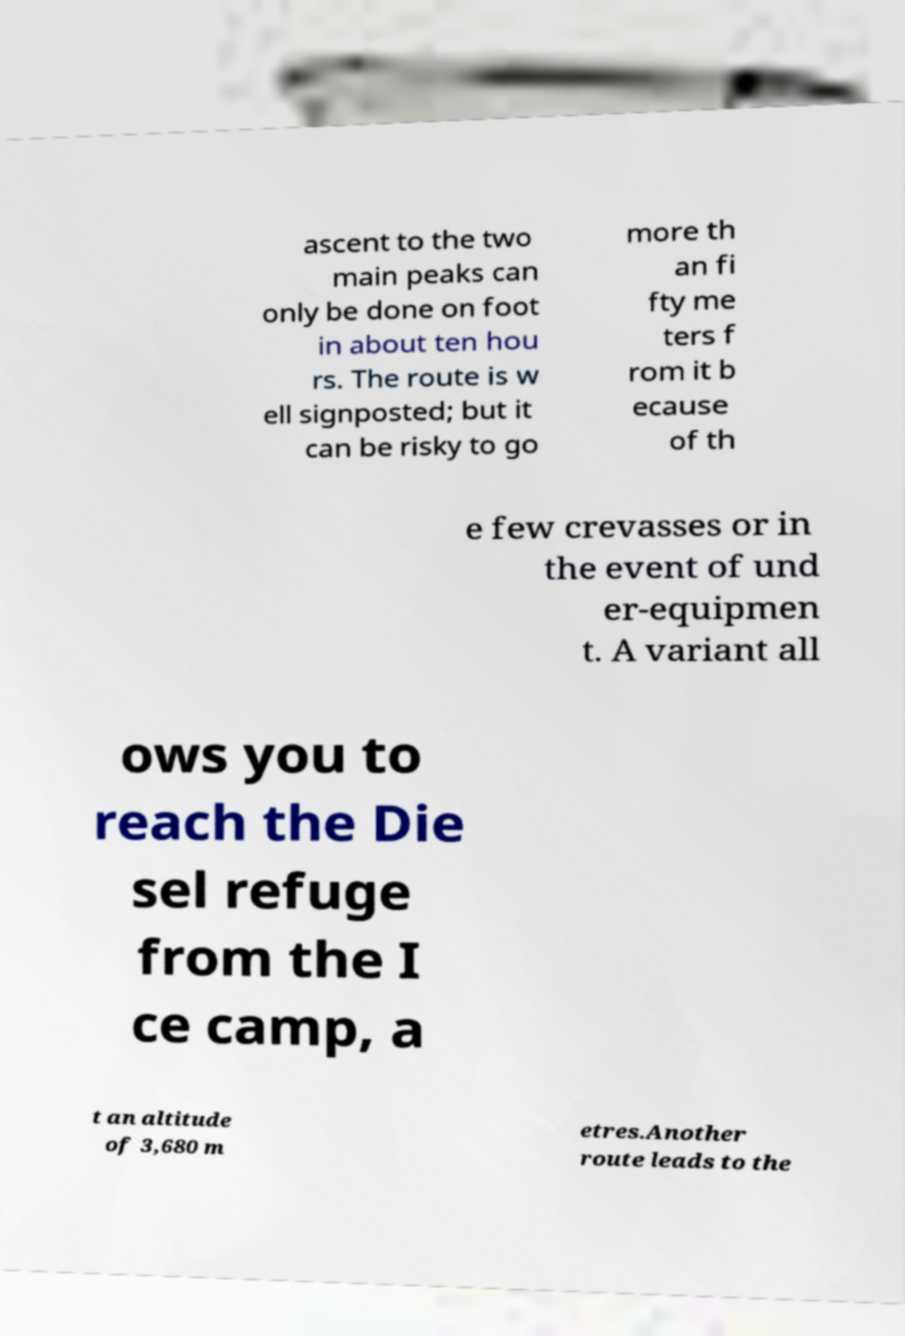What messages or text are displayed in this image? I need them in a readable, typed format. ascent to the two main peaks can only be done on foot in about ten hou rs. The route is w ell signposted; but it can be risky to go more th an fi fty me ters f rom it b ecause of th e few crevasses or in the event of und er-equipmen t. A variant all ows you to reach the Die sel refuge from the I ce camp, a t an altitude of 3,680 m etres.Another route leads to the 